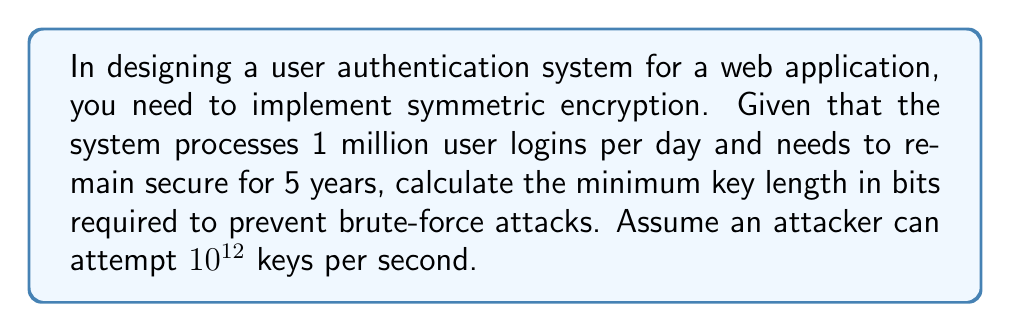Solve this math problem. To determine the optimal key length, we need to follow these steps:

1. Calculate the total number of authentication attempts over 5 years:
   $$ \text{Total attempts} = 1,000,000 \times 365 \times 5 = 1.8250 \times 10^9 $$

2. Calculate the total number of keys an attacker can try in 5 years:
   $$ \text{Attacker attempts} = 10^{12} \times 60 \times 60 \times 24 \times 365 \times 5 = 1.5768 \times 10^{20} $$

3. To ensure security, we need the key space to be significantly larger than the attacker's attempts. Let's aim for a factor of $10^6$:
   $$ \text{Required key space} = 1.5768 \times 10^{20} \times 10^6 = 1.5768 \times 10^{26} $$

4. Calculate the minimum number of bits needed to represent this key space:
   $$ 2^n \geq 1.5768 \times 10^{26} $$
   $$ n \log_2(2) \geq \log_2(1.5768 \times 10^{26}) $$
   $$ n \geq \frac{\log_2(1.5768 \times 10^{26})}{\log_2(2)} $$
   $$ n \geq 88.2 $$

5. Round up to the nearest standard key length:
   The next standard key length above 88.2 bits is 128 bits.
Answer: 128 bits 